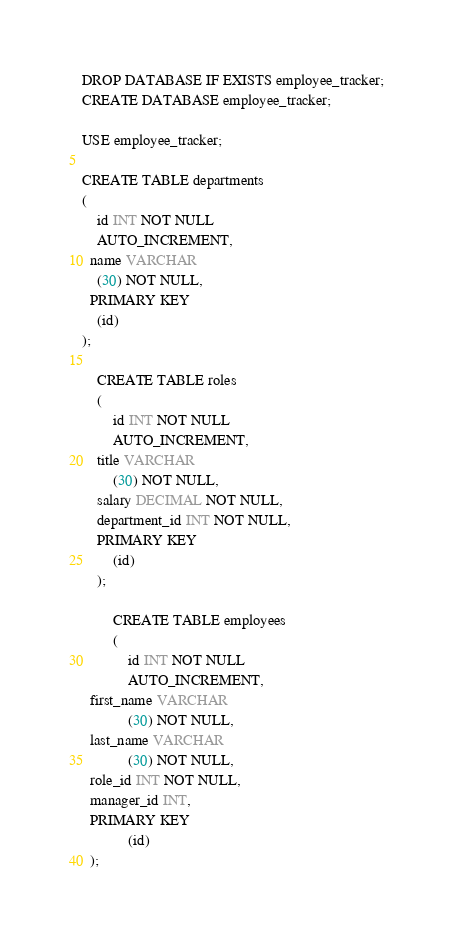<code> <loc_0><loc_0><loc_500><loc_500><_SQL_>DROP DATABASE IF EXISTS employee_tracker;
CREATE DATABASE employee_tracker;

USE employee_tracker;

CREATE TABLE departments
(
    id INT NOT NULL
    AUTO_INCREMENT,
  name VARCHAR
    (30) NOT NULL,
  PRIMARY KEY
    (id)
);

    CREATE TABLE roles
    (
        id INT NOT NULL
        AUTO_INCREMENT,
    title VARCHAR
        (30) NOT NULL,
    salary DECIMAL NOT NULL,
    department_id INT NOT NULL,
    PRIMARY KEY
        (id)
    );

        CREATE TABLE employees
        (
            id INT NOT NULL
            AUTO_INCREMENT,
  first_name VARCHAR
            (30) NOT NULL,
  last_name VARCHAR
            (30) NOT NULL,
  role_id INT NOT NULL,
  manager_id INT,
  PRIMARY KEY
            (id)
  );</code> 